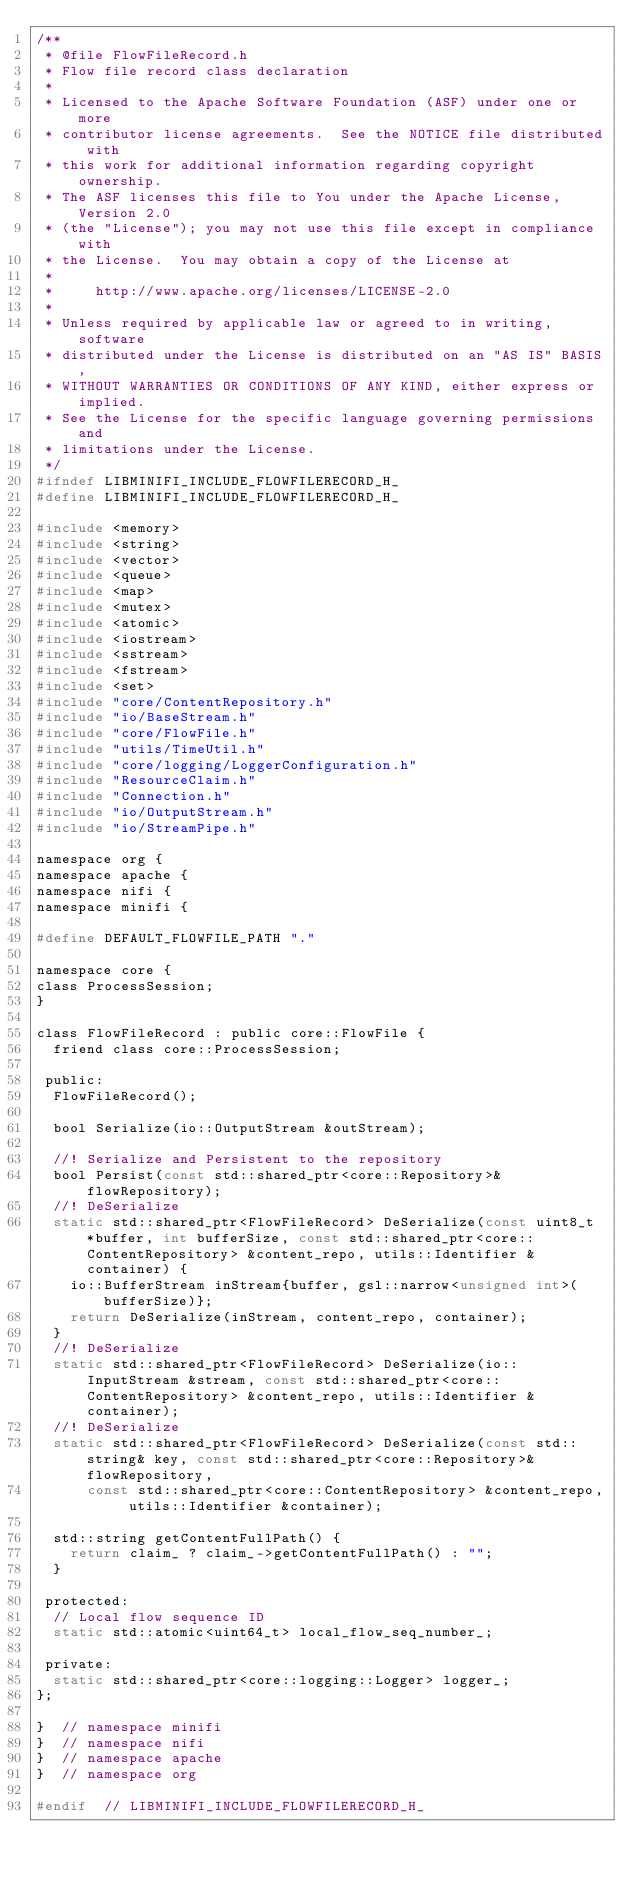Convert code to text. <code><loc_0><loc_0><loc_500><loc_500><_C_>/**
 * @file FlowFileRecord.h
 * Flow file record class declaration
 *
 * Licensed to the Apache Software Foundation (ASF) under one or more
 * contributor license agreements.  See the NOTICE file distributed with
 * this work for additional information regarding copyright ownership.
 * The ASF licenses this file to You under the Apache License, Version 2.0
 * (the "License"); you may not use this file except in compliance with
 * the License.  You may obtain a copy of the License at
 *
 *     http://www.apache.org/licenses/LICENSE-2.0
 *
 * Unless required by applicable law or agreed to in writing, software
 * distributed under the License is distributed on an "AS IS" BASIS,
 * WITHOUT WARRANTIES OR CONDITIONS OF ANY KIND, either express or implied.
 * See the License for the specific language governing permissions and
 * limitations under the License.
 */
#ifndef LIBMINIFI_INCLUDE_FLOWFILERECORD_H_
#define LIBMINIFI_INCLUDE_FLOWFILERECORD_H_

#include <memory>
#include <string>
#include <vector>
#include <queue>
#include <map>
#include <mutex>
#include <atomic>
#include <iostream>
#include <sstream>
#include <fstream>
#include <set>
#include "core/ContentRepository.h"
#include "io/BaseStream.h"
#include "core/FlowFile.h"
#include "utils/TimeUtil.h"
#include "core/logging/LoggerConfiguration.h"
#include "ResourceClaim.h"
#include "Connection.h"
#include "io/OutputStream.h"
#include "io/StreamPipe.h"

namespace org {
namespace apache {
namespace nifi {
namespace minifi {

#define DEFAULT_FLOWFILE_PATH "."

namespace core {
class ProcessSession;
}

class FlowFileRecord : public core::FlowFile {
  friend class core::ProcessSession;

 public:
  FlowFileRecord();

  bool Serialize(io::OutputStream &outStream);

  //! Serialize and Persistent to the repository
  bool Persist(const std::shared_ptr<core::Repository>& flowRepository);
  //! DeSerialize
  static std::shared_ptr<FlowFileRecord> DeSerialize(const uint8_t *buffer, int bufferSize, const std::shared_ptr<core::ContentRepository> &content_repo, utils::Identifier &container) {
    io::BufferStream inStream{buffer, gsl::narrow<unsigned int>(bufferSize)};
    return DeSerialize(inStream, content_repo, container);
  }
  //! DeSerialize
  static std::shared_ptr<FlowFileRecord> DeSerialize(io::InputStream &stream, const std::shared_ptr<core::ContentRepository> &content_repo, utils::Identifier &container);
  //! DeSerialize
  static std::shared_ptr<FlowFileRecord> DeSerialize(const std::string& key, const std::shared_ptr<core::Repository>& flowRepository,
      const std::shared_ptr<core::ContentRepository> &content_repo, utils::Identifier &container);

  std::string getContentFullPath() {
    return claim_ ? claim_->getContentFullPath() : "";
  }

 protected:
  // Local flow sequence ID
  static std::atomic<uint64_t> local_flow_seq_number_;

 private:
  static std::shared_ptr<core::logging::Logger> logger_;
};

}  // namespace minifi
}  // namespace nifi
}  // namespace apache
}  // namespace org

#endif  // LIBMINIFI_INCLUDE_FLOWFILERECORD_H_
</code> 